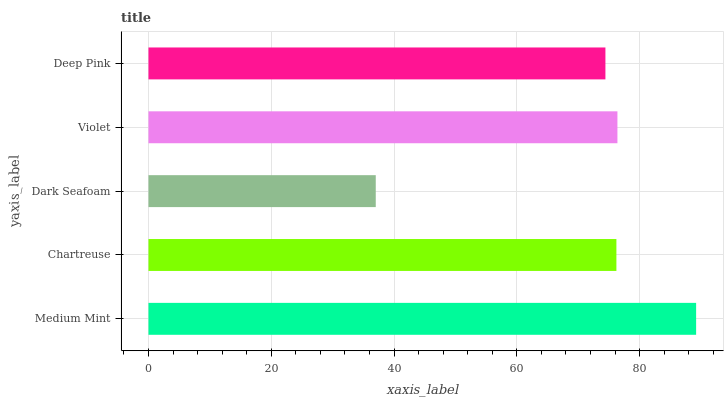Is Dark Seafoam the minimum?
Answer yes or no. Yes. Is Medium Mint the maximum?
Answer yes or no. Yes. Is Chartreuse the minimum?
Answer yes or no. No. Is Chartreuse the maximum?
Answer yes or no. No. Is Medium Mint greater than Chartreuse?
Answer yes or no. Yes. Is Chartreuse less than Medium Mint?
Answer yes or no. Yes. Is Chartreuse greater than Medium Mint?
Answer yes or no. No. Is Medium Mint less than Chartreuse?
Answer yes or no. No. Is Chartreuse the high median?
Answer yes or no. Yes. Is Chartreuse the low median?
Answer yes or no. Yes. Is Violet the high median?
Answer yes or no. No. Is Deep Pink the low median?
Answer yes or no. No. 